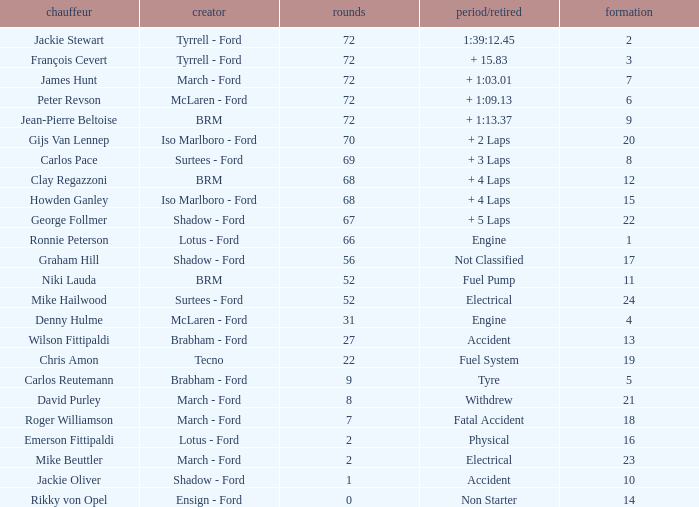Parse the full table. {'header': ['chauffeur', 'creator', 'rounds', 'period/retired', 'formation'], 'rows': [['Jackie Stewart', 'Tyrrell - Ford', '72', '1:39:12.45', '2'], ['François Cevert', 'Tyrrell - Ford', '72', '+ 15.83', '3'], ['James Hunt', 'March - Ford', '72', '+ 1:03.01', '7'], ['Peter Revson', 'McLaren - Ford', '72', '+ 1:09.13', '6'], ['Jean-Pierre Beltoise', 'BRM', '72', '+ 1:13.37', '9'], ['Gijs Van Lennep', 'Iso Marlboro - Ford', '70', '+ 2 Laps', '20'], ['Carlos Pace', 'Surtees - Ford', '69', '+ 3 Laps', '8'], ['Clay Regazzoni', 'BRM', '68', '+ 4 Laps', '12'], ['Howden Ganley', 'Iso Marlboro - Ford', '68', '+ 4 Laps', '15'], ['George Follmer', 'Shadow - Ford', '67', '+ 5 Laps', '22'], ['Ronnie Peterson', 'Lotus - Ford', '66', 'Engine', '1'], ['Graham Hill', 'Shadow - Ford', '56', 'Not Classified', '17'], ['Niki Lauda', 'BRM', '52', 'Fuel Pump', '11'], ['Mike Hailwood', 'Surtees - Ford', '52', 'Electrical', '24'], ['Denny Hulme', 'McLaren - Ford', '31', 'Engine', '4'], ['Wilson Fittipaldi', 'Brabham - Ford', '27', 'Accident', '13'], ['Chris Amon', 'Tecno', '22', 'Fuel System', '19'], ['Carlos Reutemann', 'Brabham - Ford', '9', 'Tyre', '5'], ['David Purley', 'March - Ford', '8', 'Withdrew', '21'], ['Roger Williamson', 'March - Ford', '7', 'Fatal Accident', '18'], ['Emerson Fittipaldi', 'Lotus - Ford', '2', 'Physical', '16'], ['Mike Beuttler', 'March - Ford', '2', 'Electrical', '23'], ['Jackie Oliver', 'Shadow - Ford', '1', 'Accident', '10'], ['Rikky von Opel', 'Ensign - Ford', '0', 'Non Starter', '14']]} What is the top lap that had a tyre time? 9.0. 